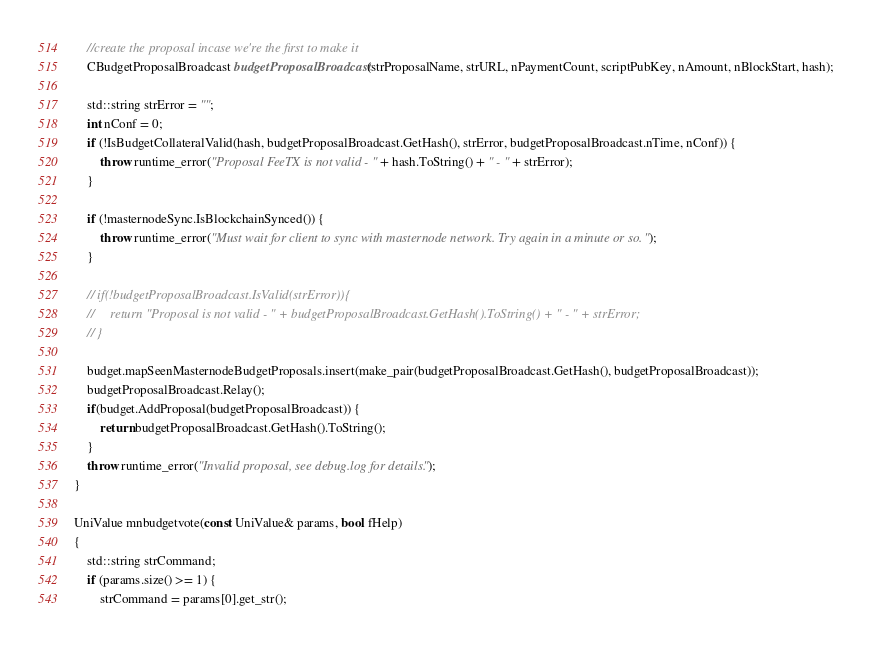<code> <loc_0><loc_0><loc_500><loc_500><_C++_>    //create the proposal incase we're the first to make it
    CBudgetProposalBroadcast budgetProposalBroadcast(strProposalName, strURL, nPaymentCount, scriptPubKey, nAmount, nBlockStart, hash);

    std::string strError = "";
    int nConf = 0;
    if (!IsBudgetCollateralValid(hash, budgetProposalBroadcast.GetHash(), strError, budgetProposalBroadcast.nTime, nConf)) {
        throw runtime_error("Proposal FeeTX is not valid - " + hash.ToString() + " - " + strError);
    }

    if (!masternodeSync.IsBlockchainSynced()) {
        throw runtime_error("Must wait for client to sync with masternode network. Try again in a minute or so.");
    }

    // if(!budgetProposalBroadcast.IsValid(strError)){
    //     return "Proposal is not valid - " + budgetProposalBroadcast.GetHash().ToString() + " - " + strError;
    // }

    budget.mapSeenMasternodeBudgetProposals.insert(make_pair(budgetProposalBroadcast.GetHash(), budgetProposalBroadcast));
    budgetProposalBroadcast.Relay();
    if(budget.AddProposal(budgetProposalBroadcast)) {
        return budgetProposalBroadcast.GetHash().ToString();
    }
    throw runtime_error("Invalid proposal, see debug.log for details.");
}

UniValue mnbudgetvote(const UniValue& params, bool fHelp)
{
    std::string strCommand;
    if (params.size() >= 1) {
        strCommand = params[0].get_str();
</code> 